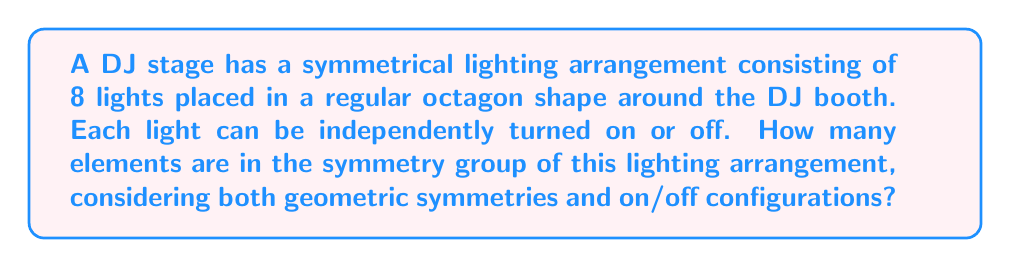Provide a solution to this math problem. To solve this problem, we need to consider two aspects of symmetry:

1. Geometric symmetries of the octagon
2. On/off configurations of the lights

Let's break it down step by step:

1. Geometric symmetries of the octagon:
   - An octagon has 8 rotational symmetries (including the identity rotation)
   - An octagon has 8 reflection symmetries (4 through vertices, 4 through midpoints of sides)
   - Total geometric symmetries: 8 + 8 = 16

2. On/off configurations:
   - Each light can be in two states (on or off)
   - There are 8 lights in total
   - Total number of on/off configurations: $2^8 = 256$

Now, we need to combine these two types of symmetries. The symmetry group of the lighting arrangement is the direct product of the octagon's symmetry group (dihedral group $D_8$) and the group of on/off configurations.

The order of the resulting group is:

$$ |G| = |D_8| \times 2^8 = 16 \times 256 = 4096 $$

This means that there are 4096 distinct symmetry operations that can be performed on the lighting arrangement, including all combinations of geometric transformations and on/off configurations.

To visualize this, we can think of each element in the symmetry group as a pair $(d, c)$, where $d$ is an element of $D_8$ (geometric symmetry) and $c$ is an 8-bit binary number representing the on/off configuration.
Answer: The symmetry group of the stage lighting arrangement has 4096 elements. 